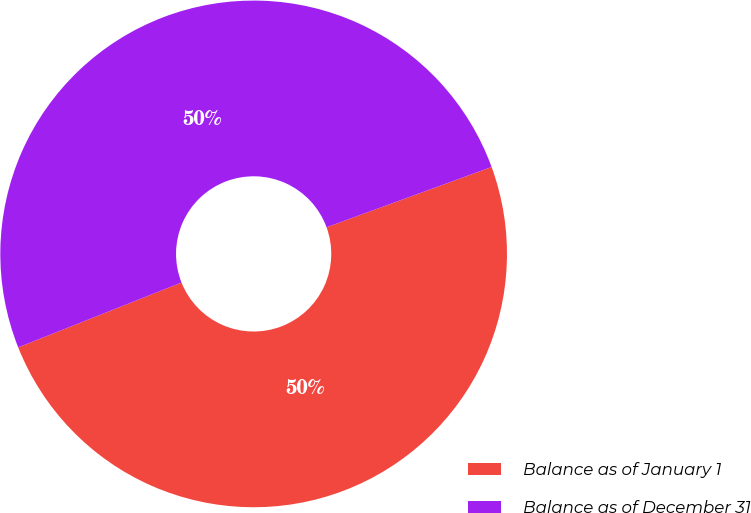<chart> <loc_0><loc_0><loc_500><loc_500><pie_chart><fcel>Balance as of January 1<fcel>Balance as of December 31<nl><fcel>49.56%<fcel>50.44%<nl></chart> 